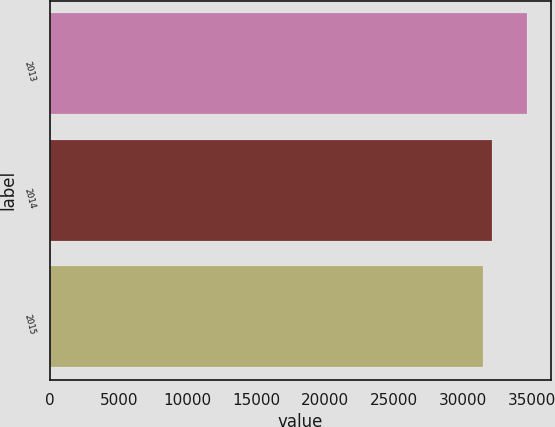Convert chart. <chart><loc_0><loc_0><loc_500><loc_500><bar_chart><fcel>2013<fcel>2014<fcel>2015<nl><fcel>34645<fcel>32141<fcel>31447<nl></chart> 